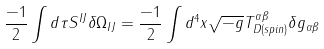<formula> <loc_0><loc_0><loc_500><loc_500>\frac { - 1 } { 2 } \int d \tau S ^ { I J } \delta \Omega _ { I J } = \frac { - 1 } { 2 } \int d ^ { 4 } x \sqrt { - g } T ^ { \alpha \beta } _ { D ( s p i n ) } \delta g _ { \alpha \beta }</formula> 